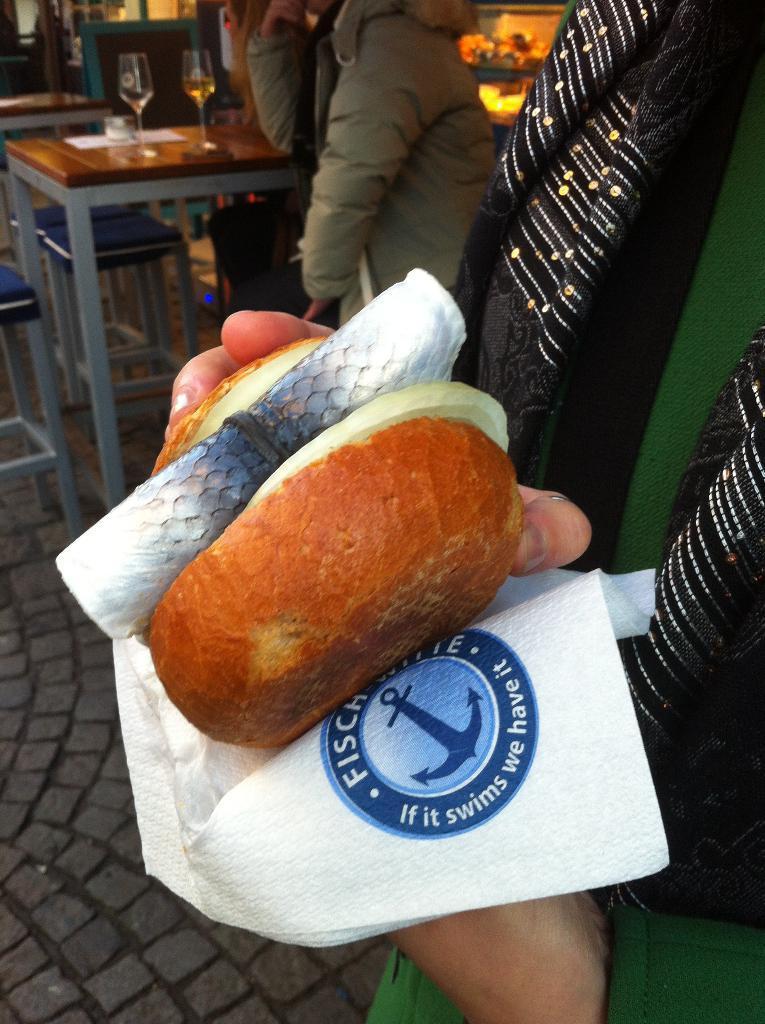In one or two sentences, can you explain what this image depicts? In this picture we can see a person standing and holding some food and a tissue paper, in the background there are chairs and tables, we can see two glasses of drinks and a paper present on this table, we can see another person here. 